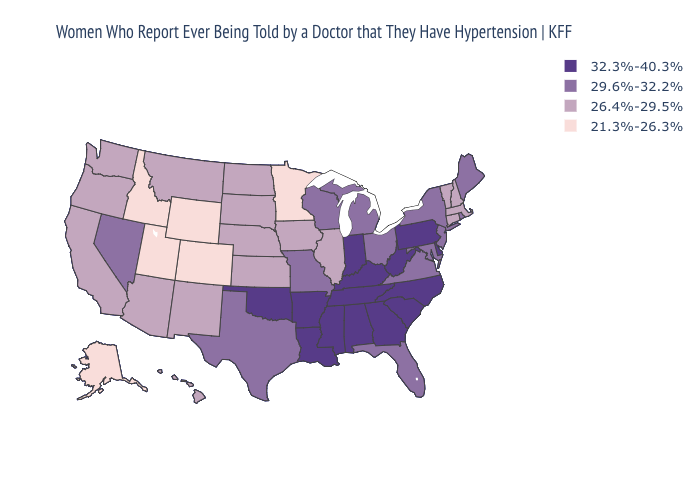Does Maryland have the lowest value in the South?
Keep it brief. Yes. Does Pennsylvania have a higher value than Tennessee?
Write a very short answer. No. Which states have the lowest value in the USA?
Concise answer only. Alaska, Colorado, Idaho, Minnesota, Utah, Wyoming. Which states hav the highest value in the West?
Quick response, please. Nevada. Among the states that border Kansas , which have the highest value?
Short answer required. Oklahoma. Name the states that have a value in the range 26.4%-29.5%?
Quick response, please. Arizona, California, Connecticut, Hawaii, Illinois, Iowa, Kansas, Massachusetts, Montana, Nebraska, New Hampshire, New Mexico, North Dakota, Oregon, South Dakota, Vermont, Washington. What is the lowest value in the USA?
Give a very brief answer. 21.3%-26.3%. Among the states that border Texas , does New Mexico have the highest value?
Quick response, please. No. What is the value of Kentucky?
Give a very brief answer. 32.3%-40.3%. Does the first symbol in the legend represent the smallest category?
Short answer required. No. What is the highest value in the MidWest ?
Short answer required. 32.3%-40.3%. What is the value of South Carolina?
Quick response, please. 32.3%-40.3%. Name the states that have a value in the range 21.3%-26.3%?
Concise answer only. Alaska, Colorado, Idaho, Minnesota, Utah, Wyoming. What is the highest value in the South ?
Keep it brief. 32.3%-40.3%. Does New Jersey have the lowest value in the Northeast?
Keep it brief. No. 